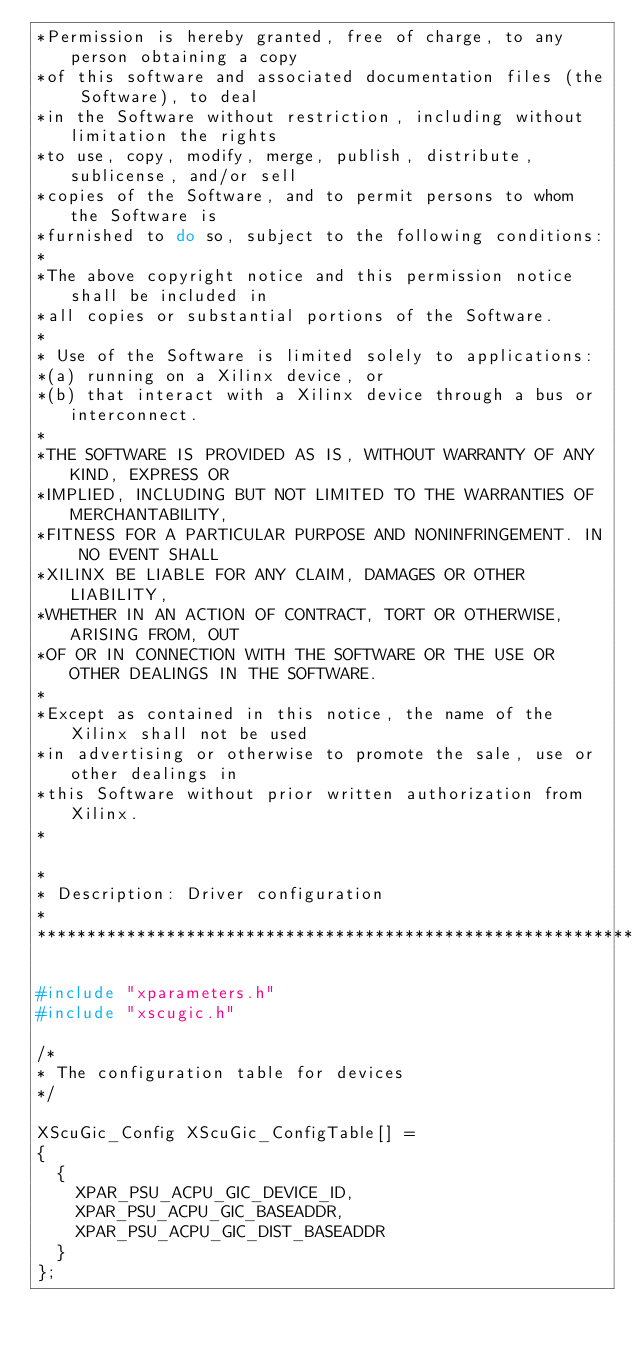Convert code to text. <code><loc_0><loc_0><loc_500><loc_500><_C_>*Permission is hereby granted, free of charge, to any person obtaining a copy
*of this software and associated documentation files (the Software), to deal
*in the Software without restriction, including without limitation the rights
*to use, copy, modify, merge, publish, distribute, sublicense, and/or sell
*copies of the Software, and to permit persons to whom the Software is
*furnished to do so, subject to the following conditions:
*
*The above copyright notice and this permission notice shall be included in
*all copies or substantial portions of the Software.
* 
* Use of the Software is limited solely to applications:
*(a) running on a Xilinx device, or
*(b) that interact with a Xilinx device through a bus or interconnect.
*
*THE SOFTWARE IS PROVIDED AS IS, WITHOUT WARRANTY OF ANY KIND, EXPRESS OR
*IMPLIED, INCLUDING BUT NOT LIMITED TO THE WARRANTIES OF MERCHANTABILITY,
*FITNESS FOR A PARTICULAR PURPOSE AND NONINFRINGEMENT. IN NO EVENT SHALL 
*XILINX BE LIABLE FOR ANY CLAIM, DAMAGES OR OTHER LIABILITY,
*WHETHER IN AN ACTION OF CONTRACT, TORT OR OTHERWISE, ARISING FROM, OUT
*OF OR IN CONNECTION WITH THE SOFTWARE OR THE USE OR OTHER DEALINGS IN THE SOFTWARE.
*
*Except as contained in this notice, the name of the Xilinx shall not be used
*in advertising or otherwise to promote the sale, use or other dealings in
*this Software without prior written authorization from Xilinx.
*

* 
* Description: Driver configuration
*
*******************************************************************/

#include "xparameters.h"
#include "xscugic.h"

/*
* The configuration table for devices
*/

XScuGic_Config XScuGic_ConfigTable[] =
{
	{
		XPAR_PSU_ACPU_GIC_DEVICE_ID,
		XPAR_PSU_ACPU_GIC_BASEADDR,
		XPAR_PSU_ACPU_GIC_DIST_BASEADDR
	}
};


</code> 